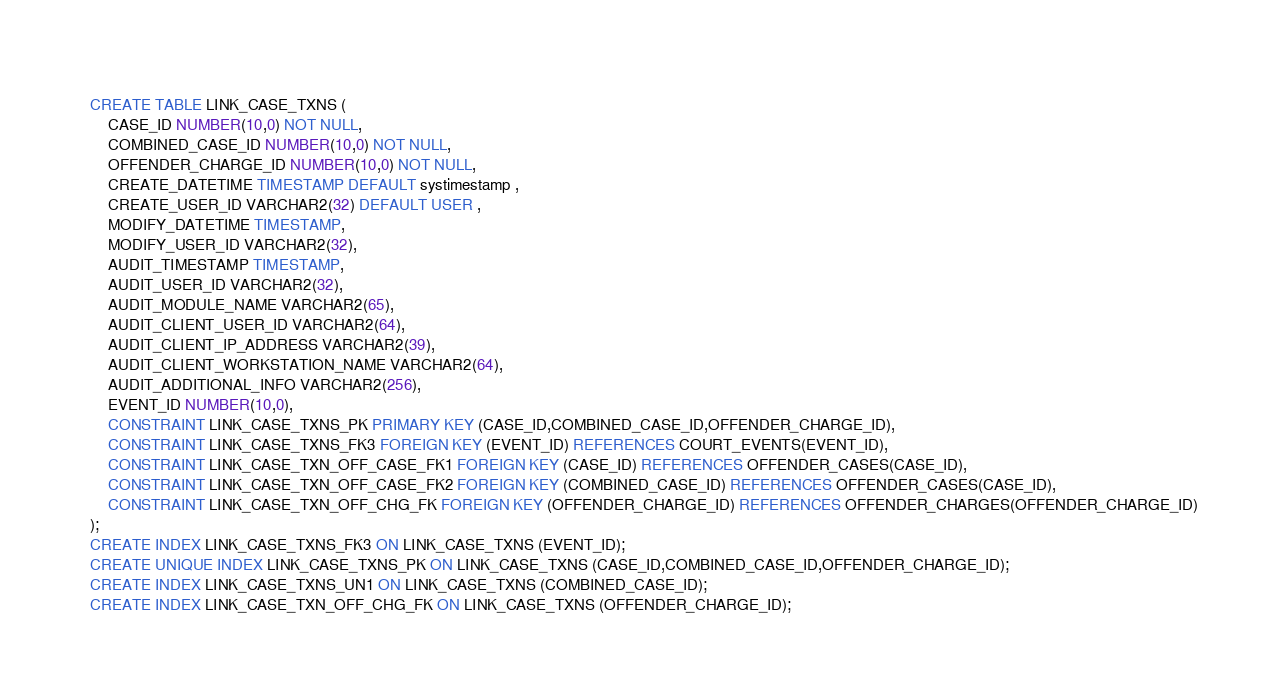Convert code to text. <code><loc_0><loc_0><loc_500><loc_500><_SQL_>CREATE TABLE LINK_CASE_TXNS (
	CASE_ID NUMBER(10,0) NOT NULL,
	COMBINED_CASE_ID NUMBER(10,0) NOT NULL,
	OFFENDER_CHARGE_ID NUMBER(10,0) NOT NULL,
	CREATE_DATETIME TIMESTAMP DEFAULT systimestamp ,
	CREATE_USER_ID VARCHAR2(32) DEFAULT USER ,
	MODIFY_DATETIME TIMESTAMP,
	MODIFY_USER_ID VARCHAR2(32),
	AUDIT_TIMESTAMP TIMESTAMP,
	AUDIT_USER_ID VARCHAR2(32),
	AUDIT_MODULE_NAME VARCHAR2(65),
	AUDIT_CLIENT_USER_ID VARCHAR2(64),
	AUDIT_CLIENT_IP_ADDRESS VARCHAR2(39),
	AUDIT_CLIENT_WORKSTATION_NAME VARCHAR2(64),
	AUDIT_ADDITIONAL_INFO VARCHAR2(256),
	EVENT_ID NUMBER(10,0),
	CONSTRAINT LINK_CASE_TXNS_PK PRIMARY KEY (CASE_ID,COMBINED_CASE_ID,OFFENDER_CHARGE_ID),
	CONSTRAINT LINK_CASE_TXNS_FK3 FOREIGN KEY (EVENT_ID) REFERENCES COURT_EVENTS(EVENT_ID),
	CONSTRAINT LINK_CASE_TXN_OFF_CASE_FK1 FOREIGN KEY (CASE_ID) REFERENCES OFFENDER_CASES(CASE_ID),
	CONSTRAINT LINK_CASE_TXN_OFF_CASE_FK2 FOREIGN KEY (COMBINED_CASE_ID) REFERENCES OFFENDER_CASES(CASE_ID),
	CONSTRAINT LINK_CASE_TXN_OFF_CHG_FK FOREIGN KEY (OFFENDER_CHARGE_ID) REFERENCES OFFENDER_CHARGES(OFFENDER_CHARGE_ID)
);
CREATE INDEX LINK_CASE_TXNS_FK3 ON LINK_CASE_TXNS (EVENT_ID);
CREATE UNIQUE INDEX LINK_CASE_TXNS_PK ON LINK_CASE_TXNS (CASE_ID,COMBINED_CASE_ID,OFFENDER_CHARGE_ID);
CREATE INDEX LINK_CASE_TXNS_UN1 ON LINK_CASE_TXNS (COMBINED_CASE_ID);
CREATE INDEX LINK_CASE_TXN_OFF_CHG_FK ON LINK_CASE_TXNS (OFFENDER_CHARGE_ID);
</code> 